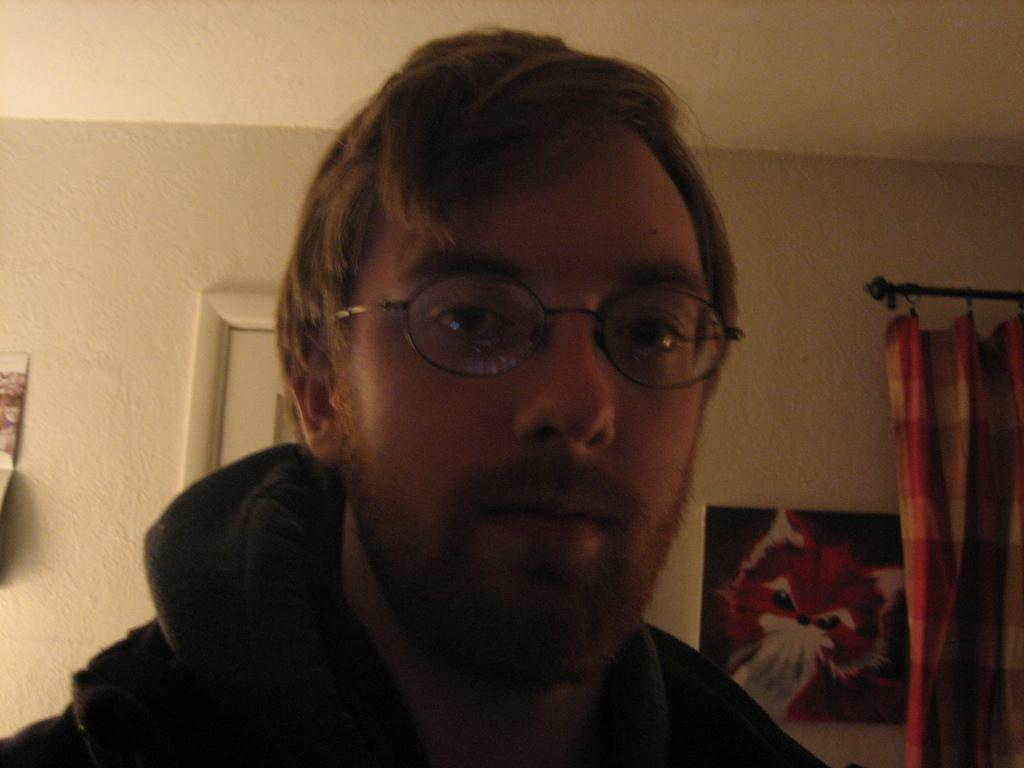Who or what is the main subject in the image? There is a person in the image. What can be seen on the wall behind the person? There are photo frames on the wall behind the person. What is on the right side of the image? There is a curtain on the right side of the image. What type of soda is being consumed by the person in the image? There is no soda present in the image, so it cannot be determined what type of soda the person might be consuming. 